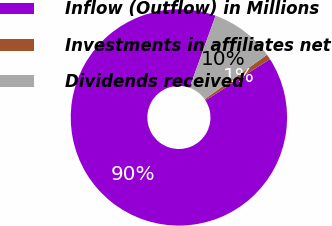Convert chart to OTSL. <chart><loc_0><loc_0><loc_500><loc_500><pie_chart><fcel>Inflow (Outflow) in Millions<fcel>Investments in affiliates net<fcel>Dividends received<nl><fcel>89.58%<fcel>0.77%<fcel>9.65%<nl></chart> 